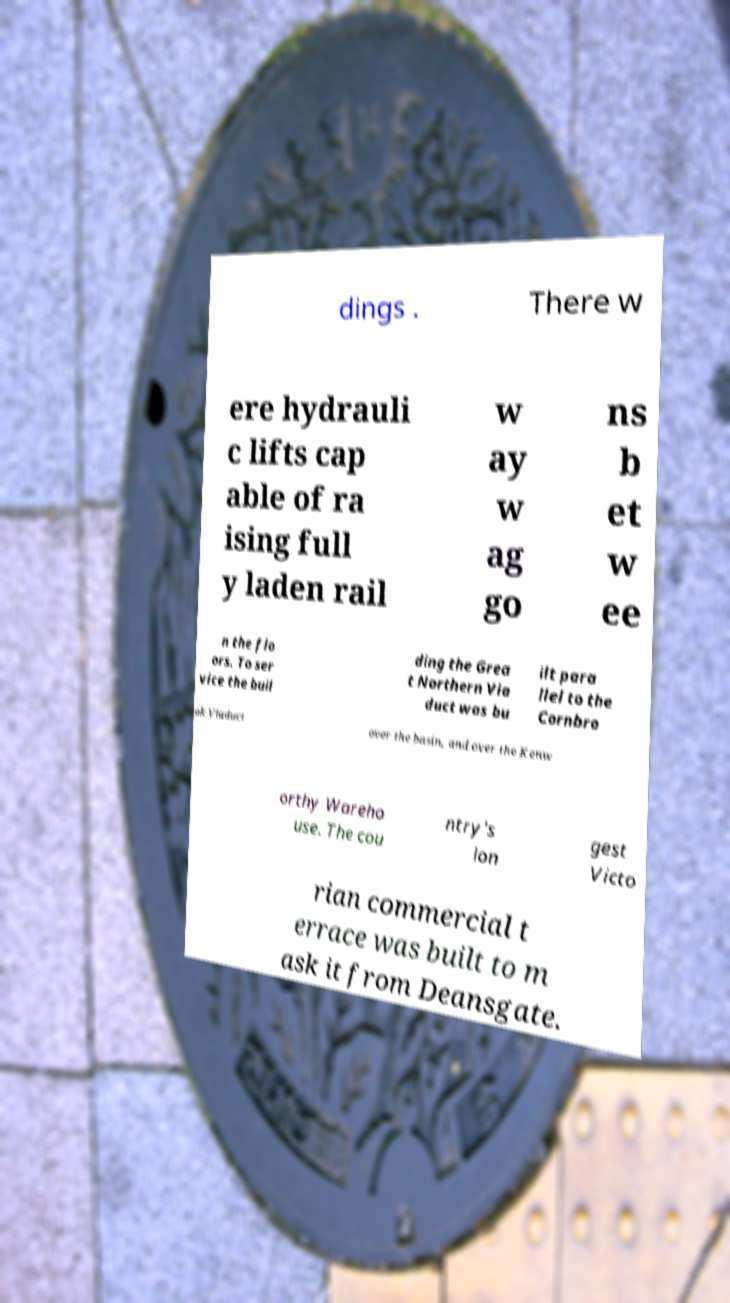Can you accurately transcribe the text from the provided image for me? dings . There w ere hydrauli c lifts cap able of ra ising full y laden rail w ay w ag go ns b et w ee n the flo ors. To ser vice the buil ding the Grea t Northern Via duct was bu ilt para llel to the Cornbro ok Viaduct over the basin, and over the Kenw orthy Wareho use. The cou ntry's lon gest Victo rian commercial t errace was built to m ask it from Deansgate. 